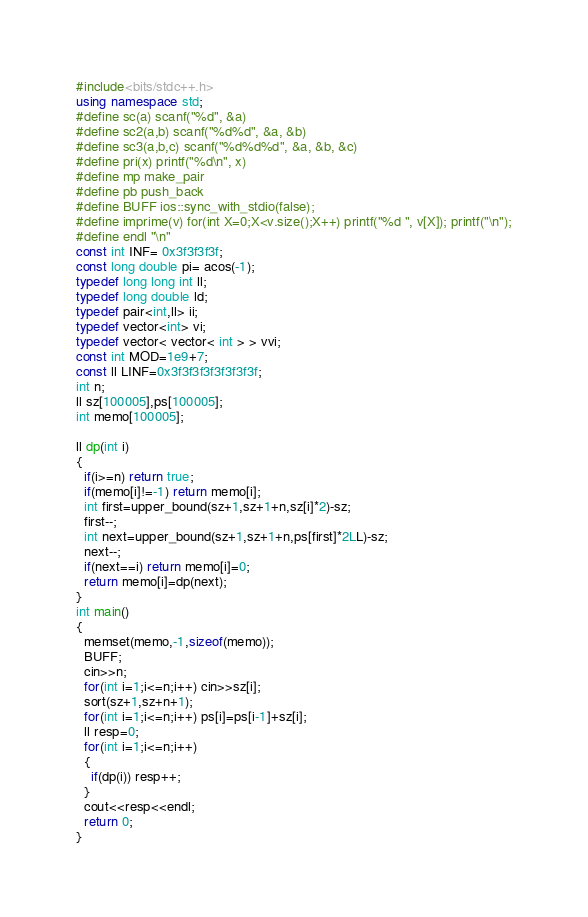<code> <loc_0><loc_0><loc_500><loc_500><_C++_>#include<bits/stdc++.h>
using namespace std;
#define sc(a) scanf("%d", &a)
#define sc2(a,b) scanf("%d%d", &a, &b)
#define sc3(a,b,c) scanf("%d%d%d", &a, &b, &c)
#define pri(x) printf("%d\n", x)
#define mp make_pair
#define pb push_back
#define BUFF ios::sync_with_stdio(false);
#define imprime(v) for(int X=0;X<v.size();X++) printf("%d ", v[X]); printf("\n");
#define endl "\n"
const int INF= 0x3f3f3f3f;
const long double pi= acos(-1);
typedef long long int ll;
typedef long double ld;
typedef pair<int,ll> ii;
typedef vector<int> vi;
typedef vector< vector< int > > vvi;
const int MOD=1e9+7;
const ll LINF=0x3f3f3f3f3f3f3f3f;
int n;
ll sz[100005],ps[100005];
int memo[100005];

ll dp(int i)
{
  if(i>=n) return true;
  if(memo[i]!=-1) return memo[i];
  int first=upper_bound(sz+1,sz+1+n,sz[i]*2)-sz;
  first--;
  int next=upper_bound(sz+1,sz+1+n,ps[first]*2LL)-sz;
  next--;
  if(next==i) return memo[i]=0;
  return memo[i]=dp(next);
}
int main()
{
  memset(memo,-1,sizeof(memo));
  BUFF;
  cin>>n;
  for(int i=1;i<=n;i++) cin>>sz[i];
  sort(sz+1,sz+n+1);
  for(int i=1;i<=n;i++) ps[i]=ps[i-1]+sz[i];
  ll resp=0;
  for(int i=1;i<=n;i++)
  {
    if(dp(i)) resp++;
  }
  cout<<resp<<endl;
  return 0;
}</code> 